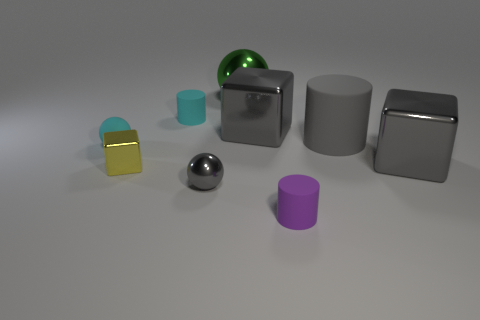Do the large gray thing that is left of the large matte cylinder and the small yellow thing have the same shape?
Offer a terse response. Yes. How many other things have the same shape as the large matte thing?
Make the answer very short. 2. Are there any other things made of the same material as the yellow object?
Make the answer very short. Yes. What is the material of the tiny cylinder that is left of the gray metal thing in front of the yellow object?
Give a very brief answer. Rubber. What size is the gray sphere that is in front of the tiny cyan ball?
Give a very brief answer. Small. Do the tiny rubber ball and the tiny cylinder that is behind the rubber ball have the same color?
Your response must be concise. Yes. Are there any big metallic things of the same color as the large ball?
Provide a succinct answer. No. Are the tiny gray object and the cylinder on the left side of the large green thing made of the same material?
Offer a terse response. No. What number of big things are yellow shiny blocks or purple cylinders?
Provide a short and direct response. 0. What is the material of the tiny object that is the same color as the big cylinder?
Your answer should be compact. Metal. 